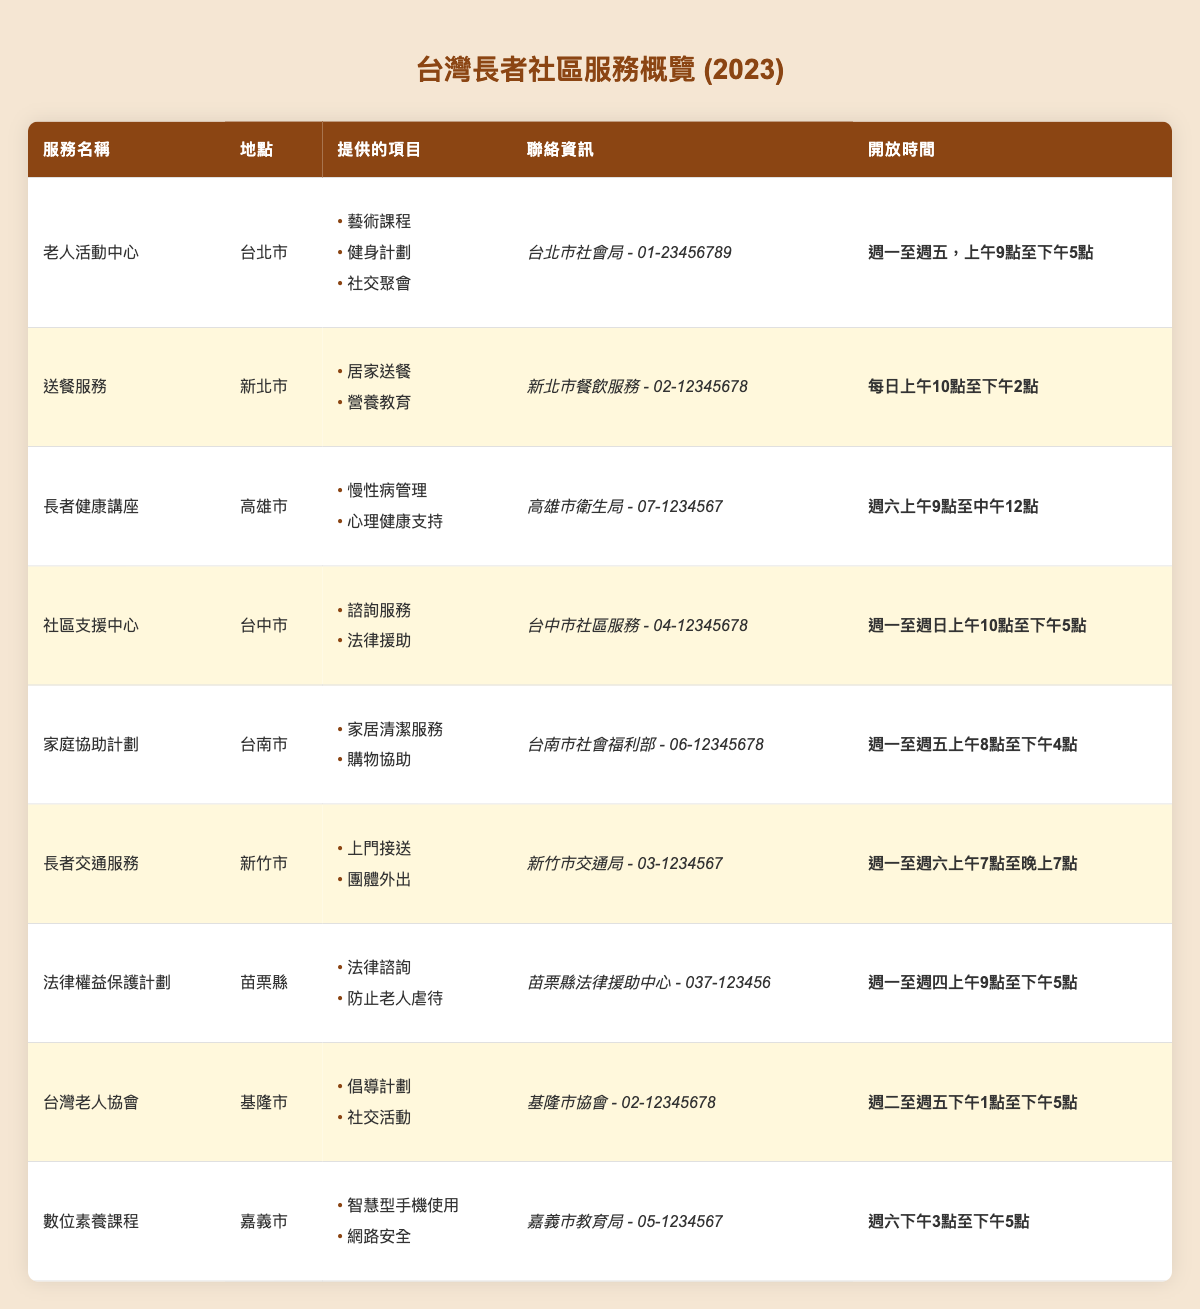What services are offered at the Senior Citizen Activity Centers in Taipei City? The table lists three services offered at the Senior Citizen Activity Centers located in Taipei City: Art Classes, Fitness Programs, and Social Gatherings.
Answer: Art Classes, Fitness Programs, Social Gatherings What are the opening hours for Meals on Wheels in New Taipei City? According to the table, the Meals on Wheels service in New Taipei City is open daily from 10 AM to 2 PM.
Answer: Daily, 10 AM - 2 PM Which city provides Legal Rights Protection Programs? The table indicates that the Legal Rights Protection Programs are available in Miaoli County.
Answer: Miaoli County How many services offer Legal Aid as one of their programs? In the table, two services offer Legal Aid: Community Support Centers in Taichung City and Legal Rights Protection Programs in Miaoli County. Thus, the total is 2.
Answer: 2 Are there any services that operate on weekends? The Seniors Health Workshops in Kaohsiung City operate on Saturdays, and the Community Support Centers in Taichung City are open on Sundays. Therefore, the answer is yes.
Answer: Yes Which service has the longest opening hours throughout the week? The Community Support Centers in Taichung City operate the longest, from 10 AM to 5 PM, seven days a week, compared to other services that are limited to weekdays or shorter hours.
Answer: Community Support Centers What is the total number of programs offered across all services listed? By counting the unique programs listed for each service (including those that may overlap), there are a total of 15 entries. Therefore, I’ll sum them: 3 + 2 + 2 + 2 + 2 + 2 + 2 + 2 + 2 = 15.
Answer: 15 Which service provides assistance with grocery shopping? The Household Assistance Program located in Tainan City provides grocery shopping assistance as one of its offerings.
Answer: Household Assistance Program What is the main focus of the Digital Literacy Classes? The Digital Literacy Classes in Chiayi City focus on two areas: Smartphone Use and Internet Safety.
Answer: Smartphone Use, Internet Safety In how many locations are the services provided? The services are listed in nine different locations: Taipei City, New Taipei City, Kaohsiung City, Taichung City, Tainan City, Hsinchu City, Miaoli County, Keelung City, and Chiayi City, totaling nine unique locations.
Answer: 9 